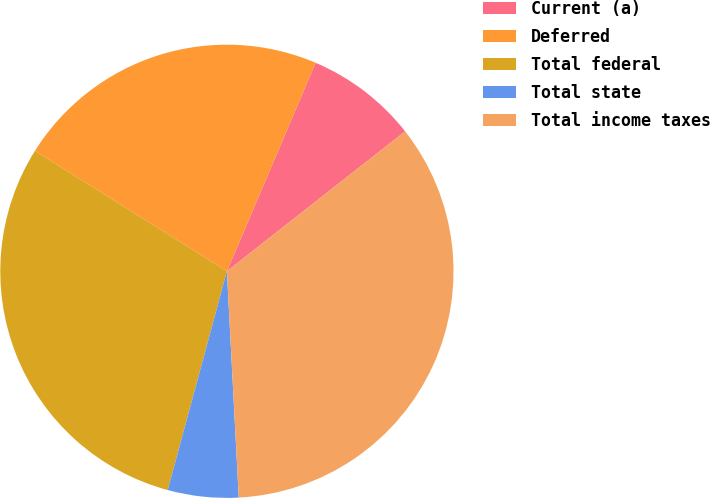Convert chart to OTSL. <chart><loc_0><loc_0><loc_500><loc_500><pie_chart><fcel>Current (a)<fcel>Deferred<fcel>Total federal<fcel>Total state<fcel>Total income taxes<nl><fcel>8.01%<fcel>22.48%<fcel>29.72%<fcel>5.04%<fcel>34.76%<nl></chart> 